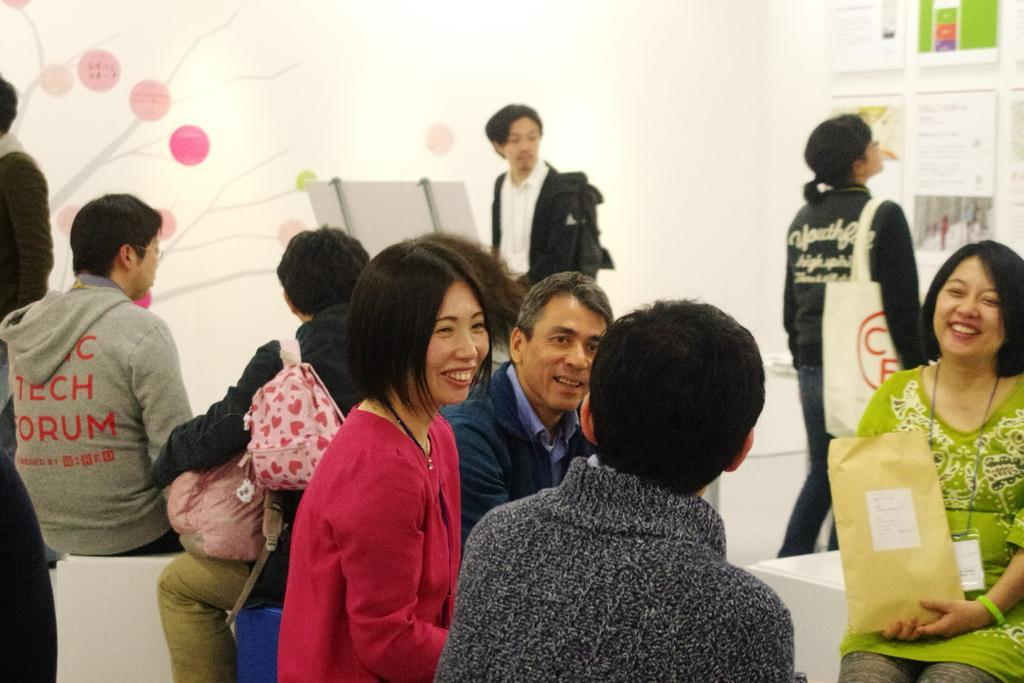How would you summarize this image in a sentence or two? In this image in front there are a few people sitting on the benches and they were smiling. Behind them there are a few other people. In the background of the image there are posters attached to the wall and we can also see the painting on the wall. 